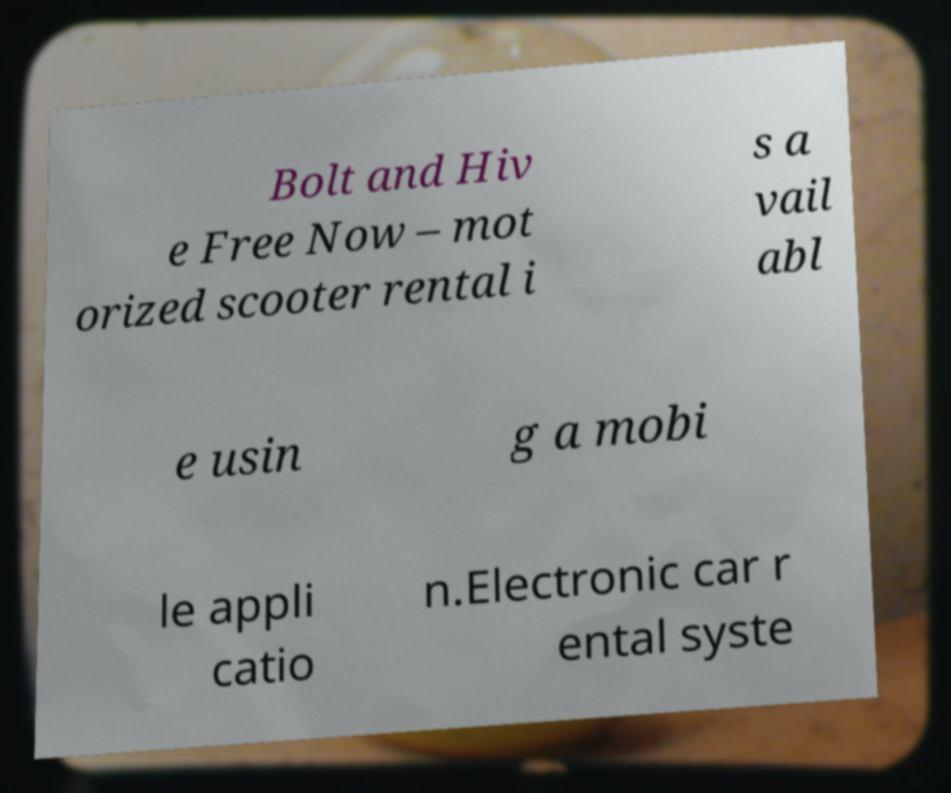Could you assist in decoding the text presented in this image and type it out clearly? Bolt and Hiv e Free Now – mot orized scooter rental i s a vail abl e usin g a mobi le appli catio n.Electronic car r ental syste 